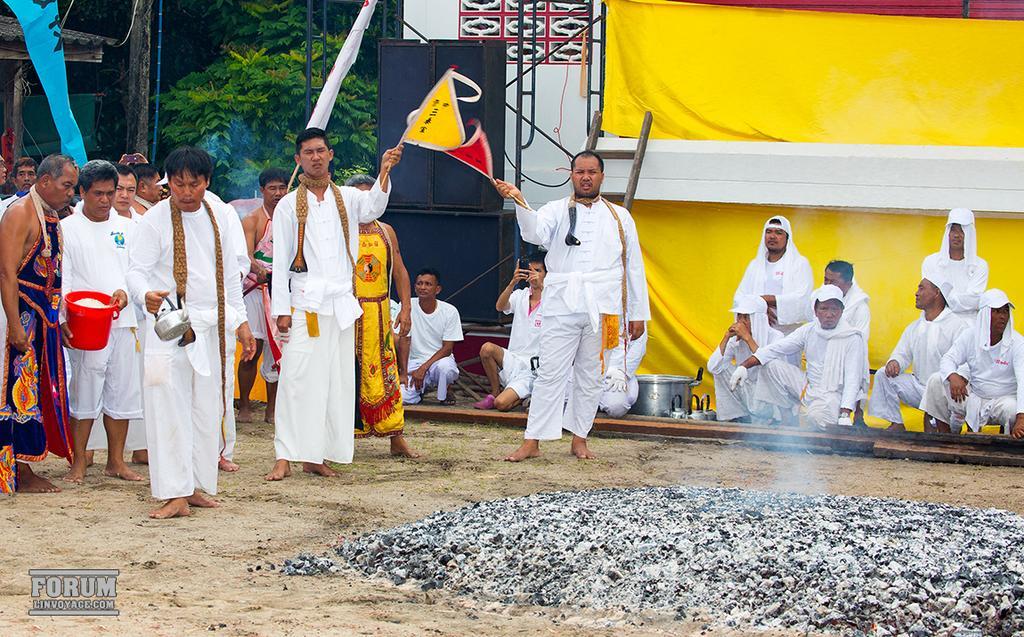Could you give a brief overview of what you see in this image? In this image in the center there are persons standing and sitting. In the front on the ground there is charcoal. In the background there is sheet which is yellow in colour, and there are black colour objects and there are trees and there is a wall which is white in colour. 